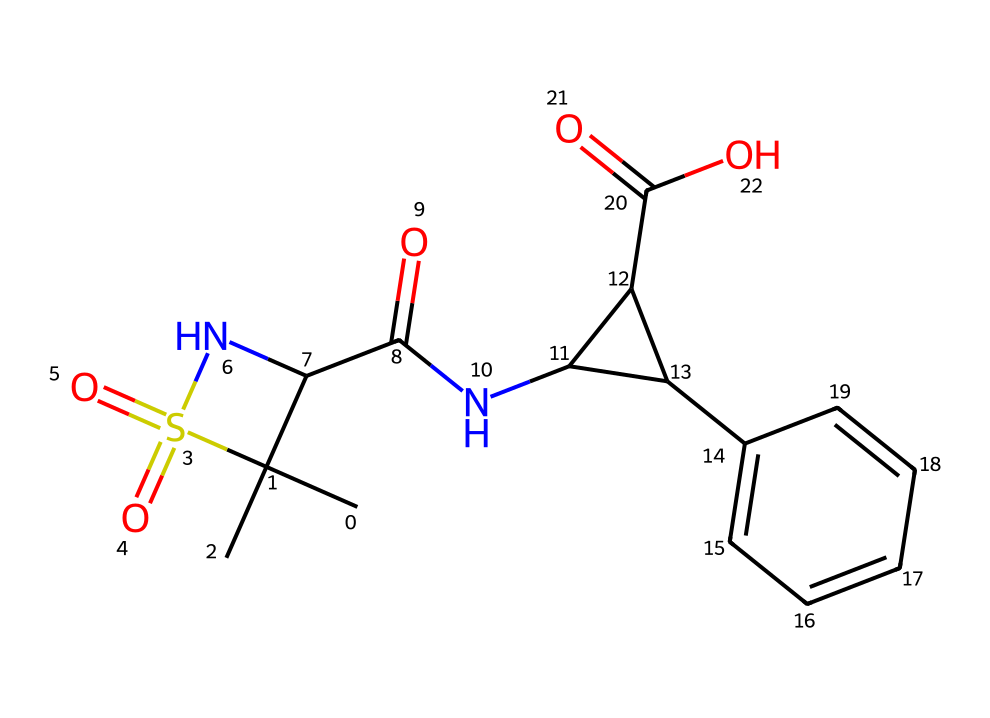How many different elements are present in this chemical? To find the number of different elements, we can identify each unique type of atom in the molecular structure. The structure shows carbon (C), hydrogen (H), nitrogen (N), oxygen (O), and sulfur (S) as distinct atoms. Counting these: there are five different elements present.
Answer: five What is the total number of rings in this chemical structure? By visual inspection, one can count the number of cyclic structures in the SMILES representation. The notation reveals three interconnected cycles, thus totaling three rings.
Answer: three Which functional group is present in this chemical? Analyzing the structure reveals the presence of a sulfonamide group (–S(=O)(=O)–N) and amide groups (–C(=O)N–). The striking feature identifying the functional group is the sulfonamide's sulfur atom and the nitrogen atom bonded, indicating the sulfonamide functional group is present.
Answer: sulfonamide How many carbon atoms are present in this structure? By examining the molecular formula derived from the structural information, one can count the number of carbon atoms. The structure has a total of 15 carbon atoms depicted.
Answer: fifteen What type of chemical behavior might this drug exhibit due to its nitrogen atoms? The presence of nitrogen atoms plays a crucial role in determining basicity. Generally, nitrogen in amines and amides can accept protons, which indicates that this drug may exhibit basic behavior and form salts, enhancing its solubility and biological activity.
Answer: basic behavior What is the significance of the cyclic structure in terms of drug activity? The cyclic structures often enhance the stability and selective binding of the drug to its target, such as enzymes or receptors. This particular arrangement can influence the overall pharmacodynamics of the drug, allowing it to effectively modulate biological pathways.
Answer: enhances binding Does this chemical have potential antibiotic properties? Given the structural components and the presence of amide and sulfonamide groups, which are commonly found in antibiotics, combined with the historical context of penicillin derivatives, it suggests potential antibiotic activity.
Answer: potential antibiotic properties 